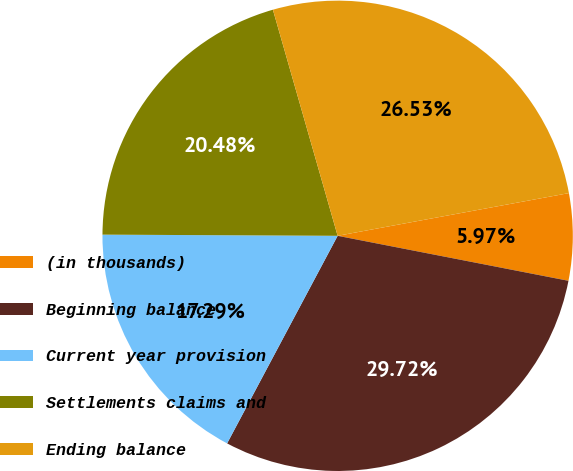Convert chart. <chart><loc_0><loc_0><loc_500><loc_500><pie_chart><fcel>(in thousands)<fcel>Beginning balance<fcel>Current year provision<fcel>Settlements claims and<fcel>Ending balance<nl><fcel>5.97%<fcel>29.72%<fcel>17.29%<fcel>20.48%<fcel>26.53%<nl></chart> 